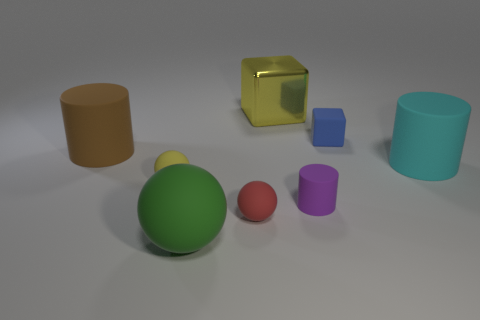Does the big object behind the blue rubber object have the same color as the tiny sphere that is behind the small rubber cylinder?
Keep it short and to the point. Yes. Is there anything else of the same color as the big metal cube?
Give a very brief answer. Yes. Are there any tiny yellow rubber cylinders?
Your answer should be compact. No. Are there any purple matte cylinders to the left of the brown rubber object?
Give a very brief answer. No. There is a cyan thing that is the same shape as the purple thing; what is its material?
Your response must be concise. Rubber. Is there anything else that is made of the same material as the large yellow thing?
Your response must be concise. No. How many other objects are the same shape as the brown matte thing?
Give a very brief answer. 2. What number of purple matte cylinders are in front of the rubber cylinder behind the large cyan rubber cylinder that is in front of the brown matte cylinder?
Make the answer very short. 1. What number of small red rubber objects are the same shape as the blue object?
Your answer should be very brief. 0. There is a ball that is behind the tiny purple rubber thing; does it have the same color as the large metallic cube?
Your response must be concise. Yes. 